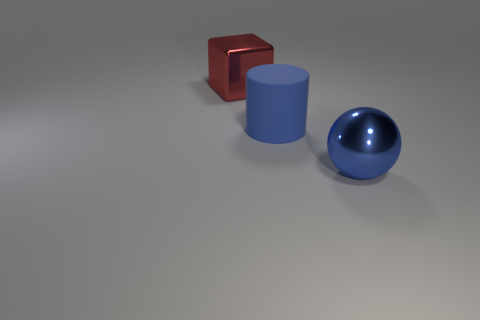Add 1 big blue matte cylinders. How many objects exist? 4 Subtract all big red matte cubes. Subtract all blue cylinders. How many objects are left? 2 Add 3 blue objects. How many blue objects are left? 5 Add 3 shiny balls. How many shiny balls exist? 4 Subtract 0 yellow cubes. How many objects are left? 3 Subtract all cylinders. How many objects are left? 2 